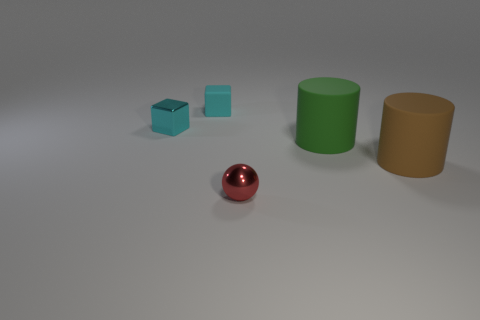What is the shape of the objects displayed? The image presents objects with geometric shapes: there are two cubes, one cylinder, and one sphere. Which object stands out the most to you, and why? The red sphere stands out due to its vibrant color and reflective surface, which contrasts with the other more muted colors and matte textures in the image. 